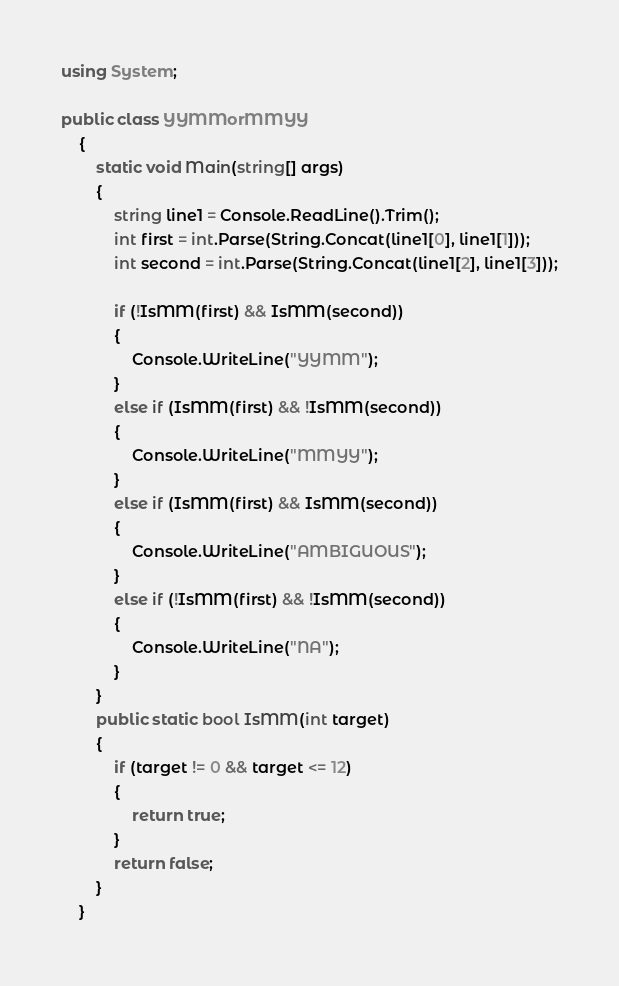Convert code to text. <code><loc_0><loc_0><loc_500><loc_500><_C#_>using System;

public class YYMMorMMYY
    {
        static void Main(string[] args)
        {           
            string line1 = Console.ReadLine().Trim();
            int first = int.Parse(String.Concat(line1[0], line1[1]));
            int second = int.Parse(String.Concat(line1[2], line1[3]));
          
            if (!IsMM(first) && IsMM(second))
            {
                Console.WriteLine("YYMM");
            }
            else if (IsMM(first) && !IsMM(second))
            {
                Console.WriteLine("MMYY");
            }
            else if (IsMM(first) && IsMM(second))
            {
                Console.WriteLine("AMBIGUOUS");
            }
            else if (!IsMM(first) && !IsMM(second))
            {
                Console.WriteLine("NA");
            }
        }
        public static bool IsMM(int target)
        {
            if (target != 0 && target <= 12)
            {
                return true;
            }
            return false;
        }
    }</code> 